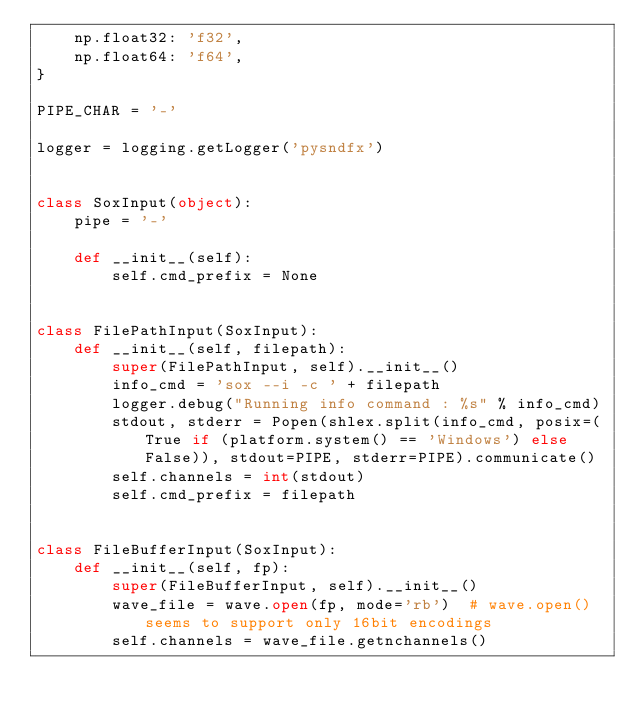Convert code to text. <code><loc_0><loc_0><loc_500><loc_500><_Python_>    np.float32: 'f32',
    np.float64: 'f64',
}

PIPE_CHAR = '-'

logger = logging.getLogger('pysndfx')


class SoxInput(object):
    pipe = '-'

    def __init__(self):
        self.cmd_prefix = None


class FilePathInput(SoxInput):
    def __init__(self, filepath):
        super(FilePathInput, self).__init__()
        info_cmd = 'sox --i -c ' + filepath
        logger.debug("Running info command : %s" % info_cmd)
        stdout, stderr = Popen(shlex.split(info_cmd, posix=(True if (platform.system() == 'Windows') else False)), stdout=PIPE, stderr=PIPE).communicate()
        self.channels = int(stdout)
        self.cmd_prefix = filepath


class FileBufferInput(SoxInput):
    def __init__(self, fp):
        super(FileBufferInput, self).__init__()
        wave_file = wave.open(fp, mode='rb')  # wave.open() seems to support only 16bit encodings
        self.channels = wave_file.getnchannels()</code> 